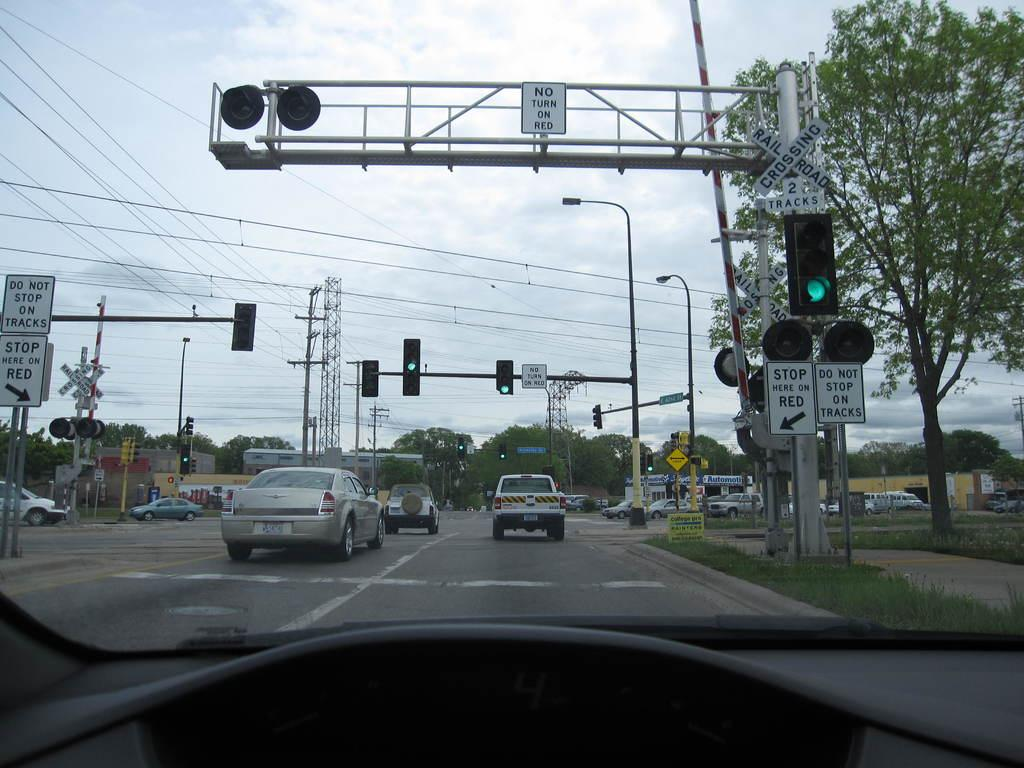Provide a one-sentence caption for the provided image. A white sign tells drivers not to stop on the tracks. 